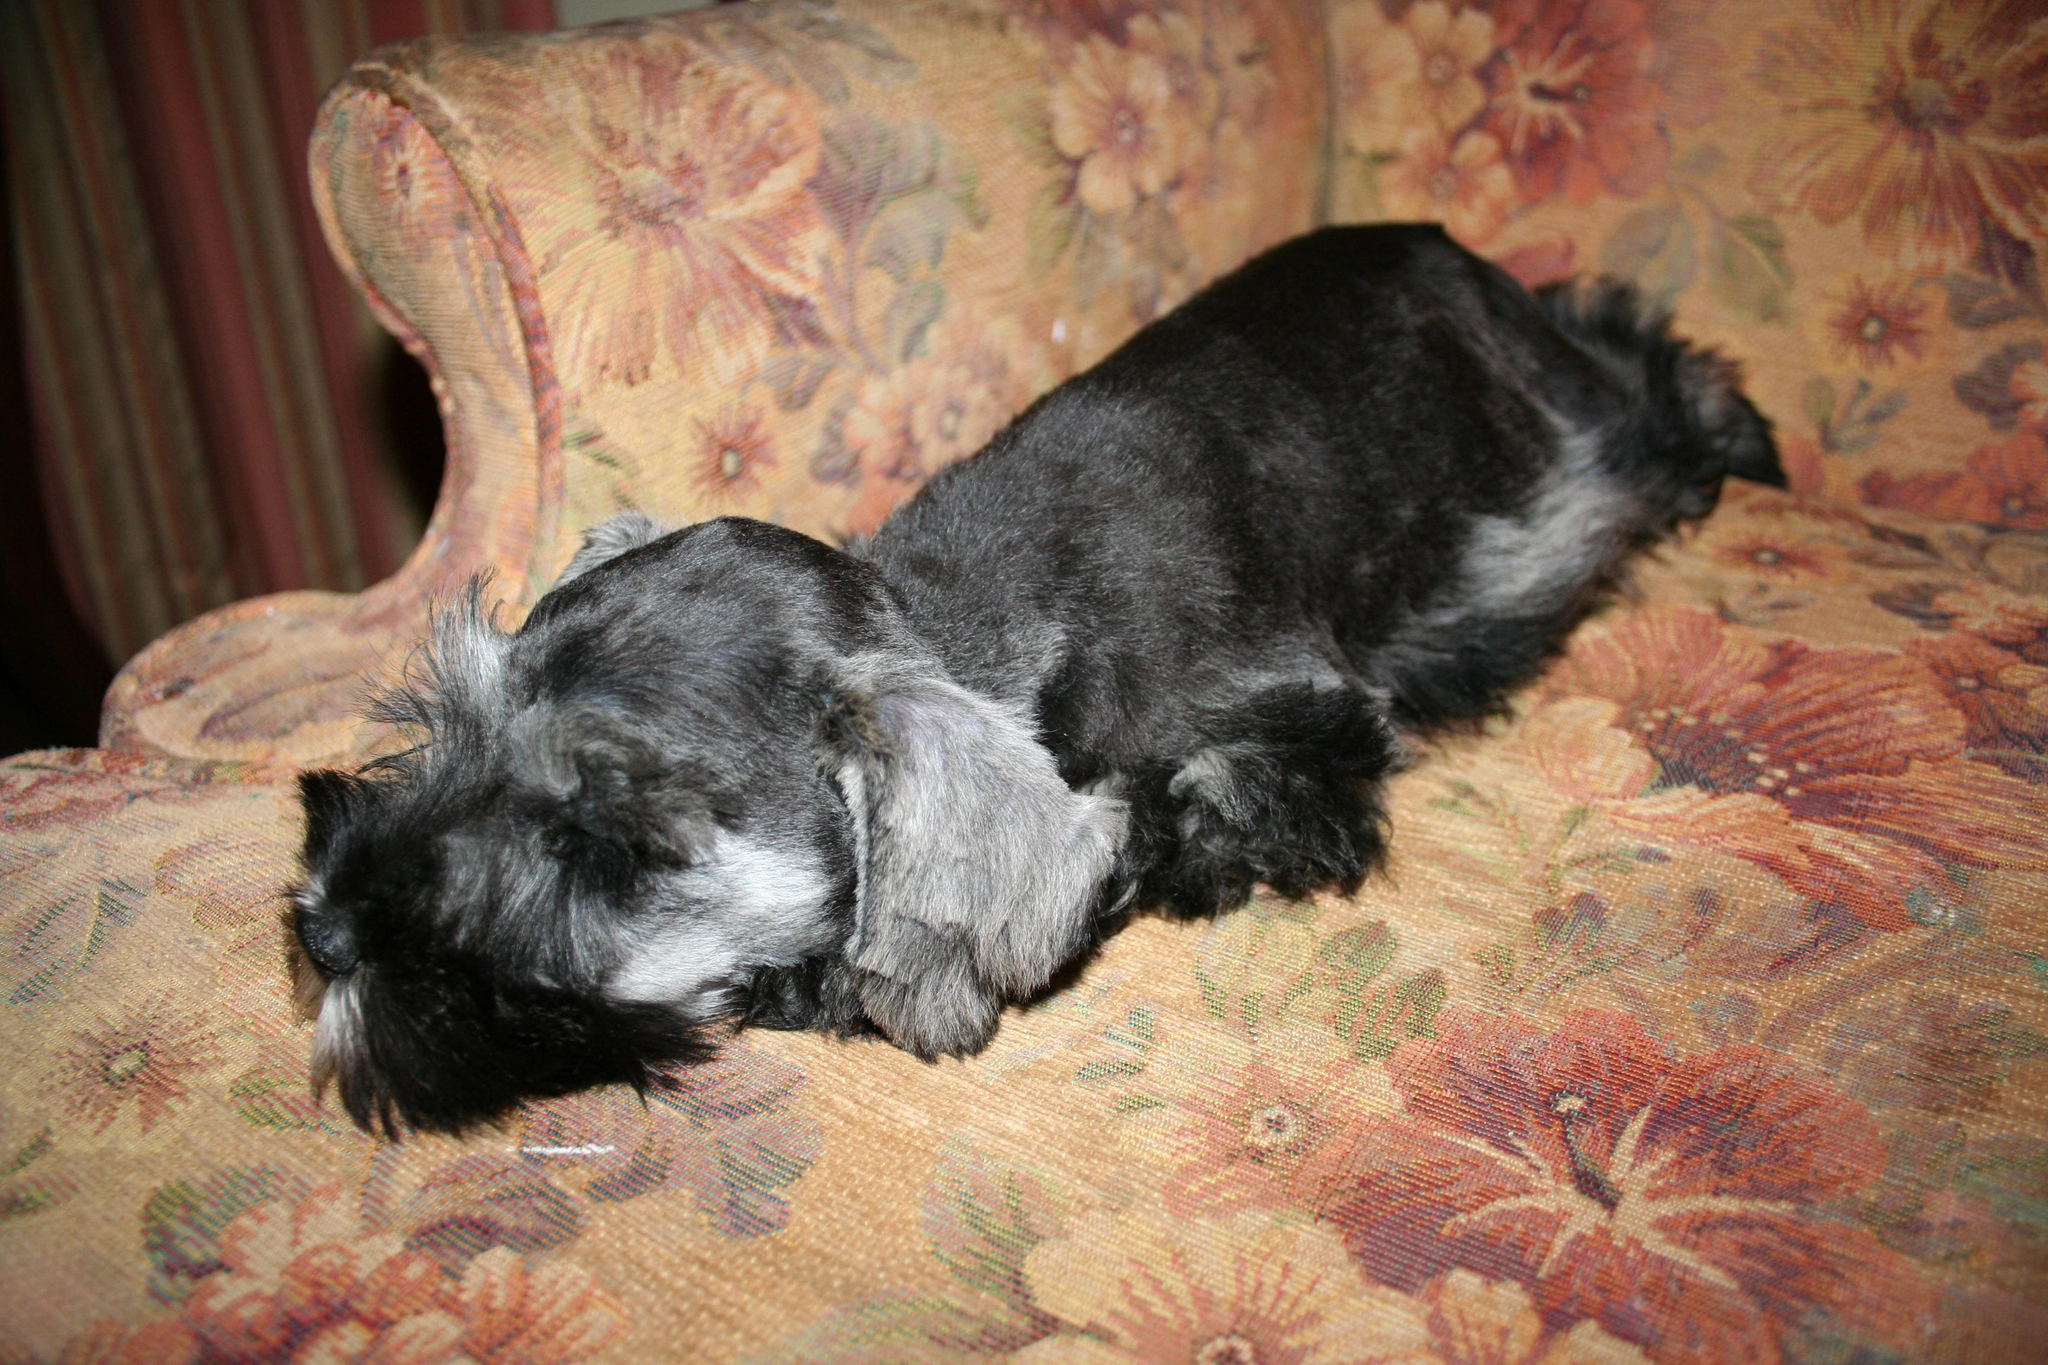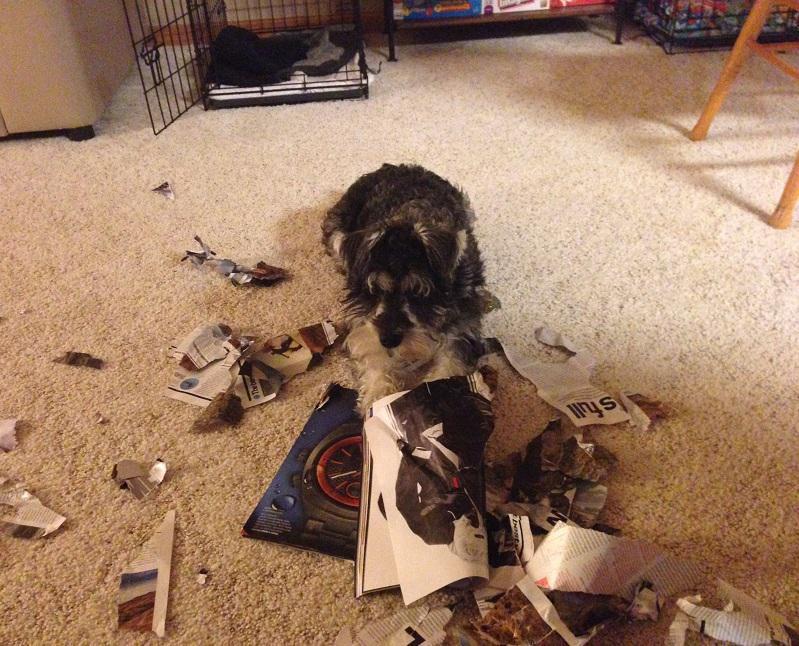The first image is the image on the left, the second image is the image on the right. For the images displayed, is the sentence "An image shows a schnauzer on its back with paws in the air." factually correct? Answer yes or no. No. The first image is the image on the left, the second image is the image on the right. Examine the images to the left and right. Is the description "A dog is sleeping on a couch." accurate? Answer yes or no. Yes. 